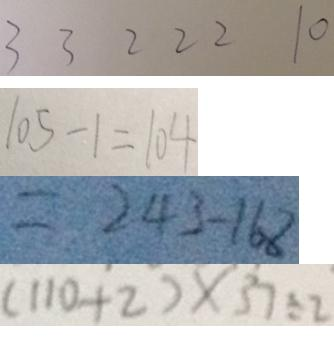Convert formula to latex. <formula><loc_0><loc_0><loc_500><loc_500>3 3 2 2 2 1 0 
 1 0 5 - 1 = 1 0 4 
 = 2 4 3 - 1 6 8 
 ( 1 1 0 + 2 ) \times 3 7 \div 2</formula> 